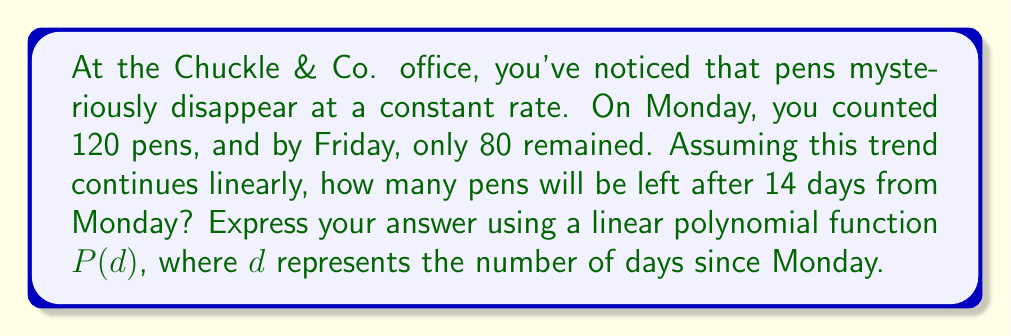Provide a solution to this math problem. Let's approach this step-by-step:

1) First, we need to find the rate of pen disappearance per day.
   - Initial number of pens (Monday): 120
   - Number of pens on Friday: 80
   - Days between Monday and Friday: 4
   
2) Calculate the rate of decrease:
   $\text{Rate} = \frac{\text{Change in pens}}{\text{Number of days}} = \frac{120 - 80}{4} = 10$ pens/day

3) Now we can form our linear polynomial function:
   $P(d) = 120 - 10d$
   Where:
   - 120 is the initial number of pens
   - -10 is the rate of decrease per day
   - $d$ is the number of days since Monday

4) To find the number of pens after 14 days, we substitute $d = 14$ into our function:
   $P(14) = 120 - 10(14) = 120 - 140 = -20$

5) However, we can't have a negative number of pens. This means all pens will be gone before 14 days.

6) To find when the pens run out, we solve:
   $0 = 120 - 10d$
   $10d = 120$
   $d = 12$

Therefore, all pens will be gone after 12 days.
Answer: $P(d) = 120 - 10d$, where $d \leq 12$ 